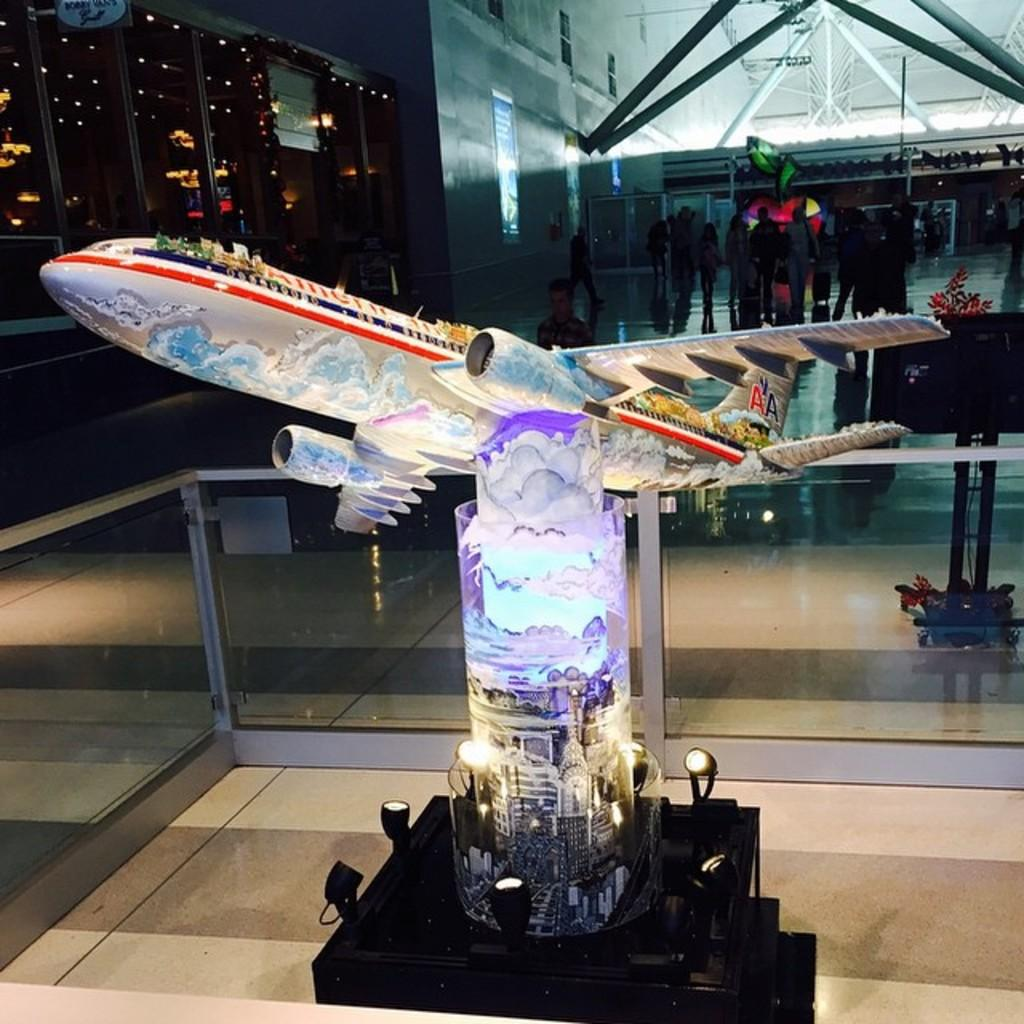What is the main object on the architecture in the image? There is an airplane on the architecture in the image. Where is the architecture located? The architecture is on a table in the image. What can be seen in the image that provides illumination? There are lights in the image. What is the group of people doing in the image? There is a group of people standing in the image. What type of material is used for the rods in the image? Iron rods are present in the image. What is attached to the wall in the image? Boards are attached to the wall in the image. What type of voice can be heard coming from the stranger in the image? There is no stranger present in the image, so it is not possible to determine what type of voice might be heard. What direction is the train moving in the image? There is no train present in the image, so it is not possible to determine the direction of movement. 